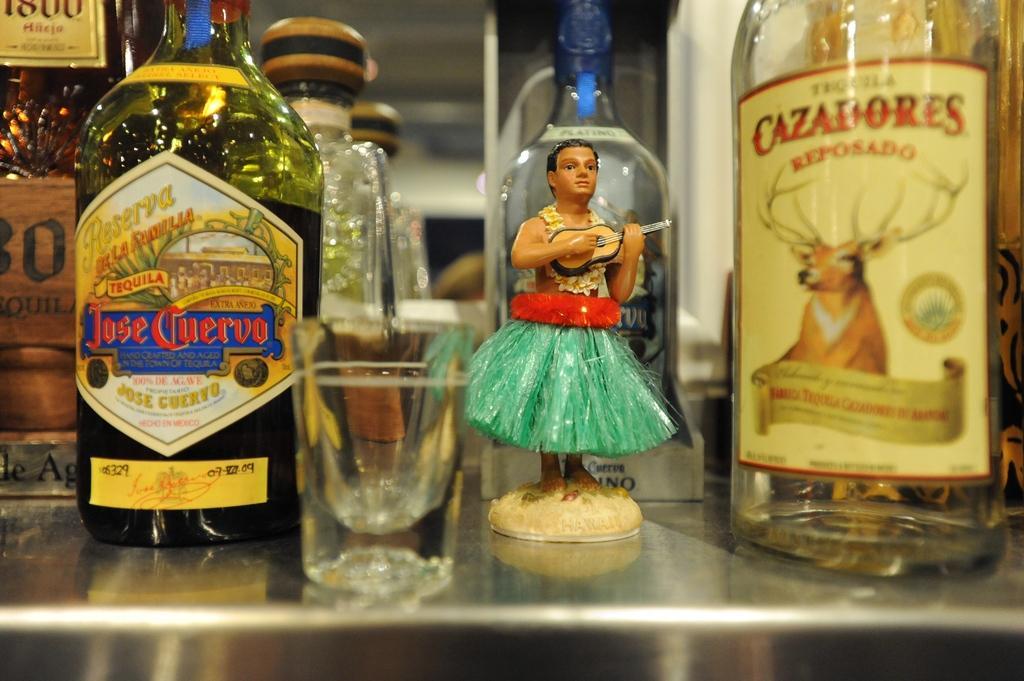Could you give a brief overview of what you see in this image? Here are the glass bottles and a tumbler and this is the toy placed on the table. And these bottles are closed with a cockpit. 